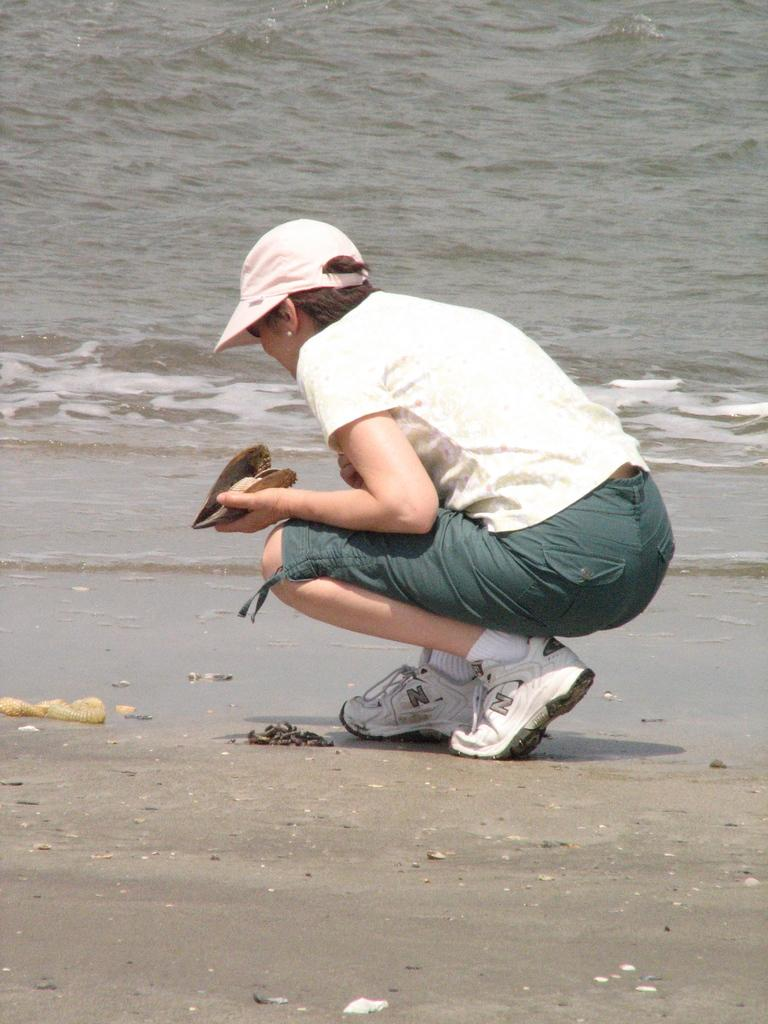Who is the main subject in the image? There is a woman in the center of the image. What is the woman doing in the image? The woman is in a squatting position. What is the woman holding in her hand? The woman is holding an object in her hand. What can be seen in the background of the image? There is water visible in the background of the image. What type of nose can be seen on the woman in the image? There is no nose visible on the woman in the image, as her face is not shown. 